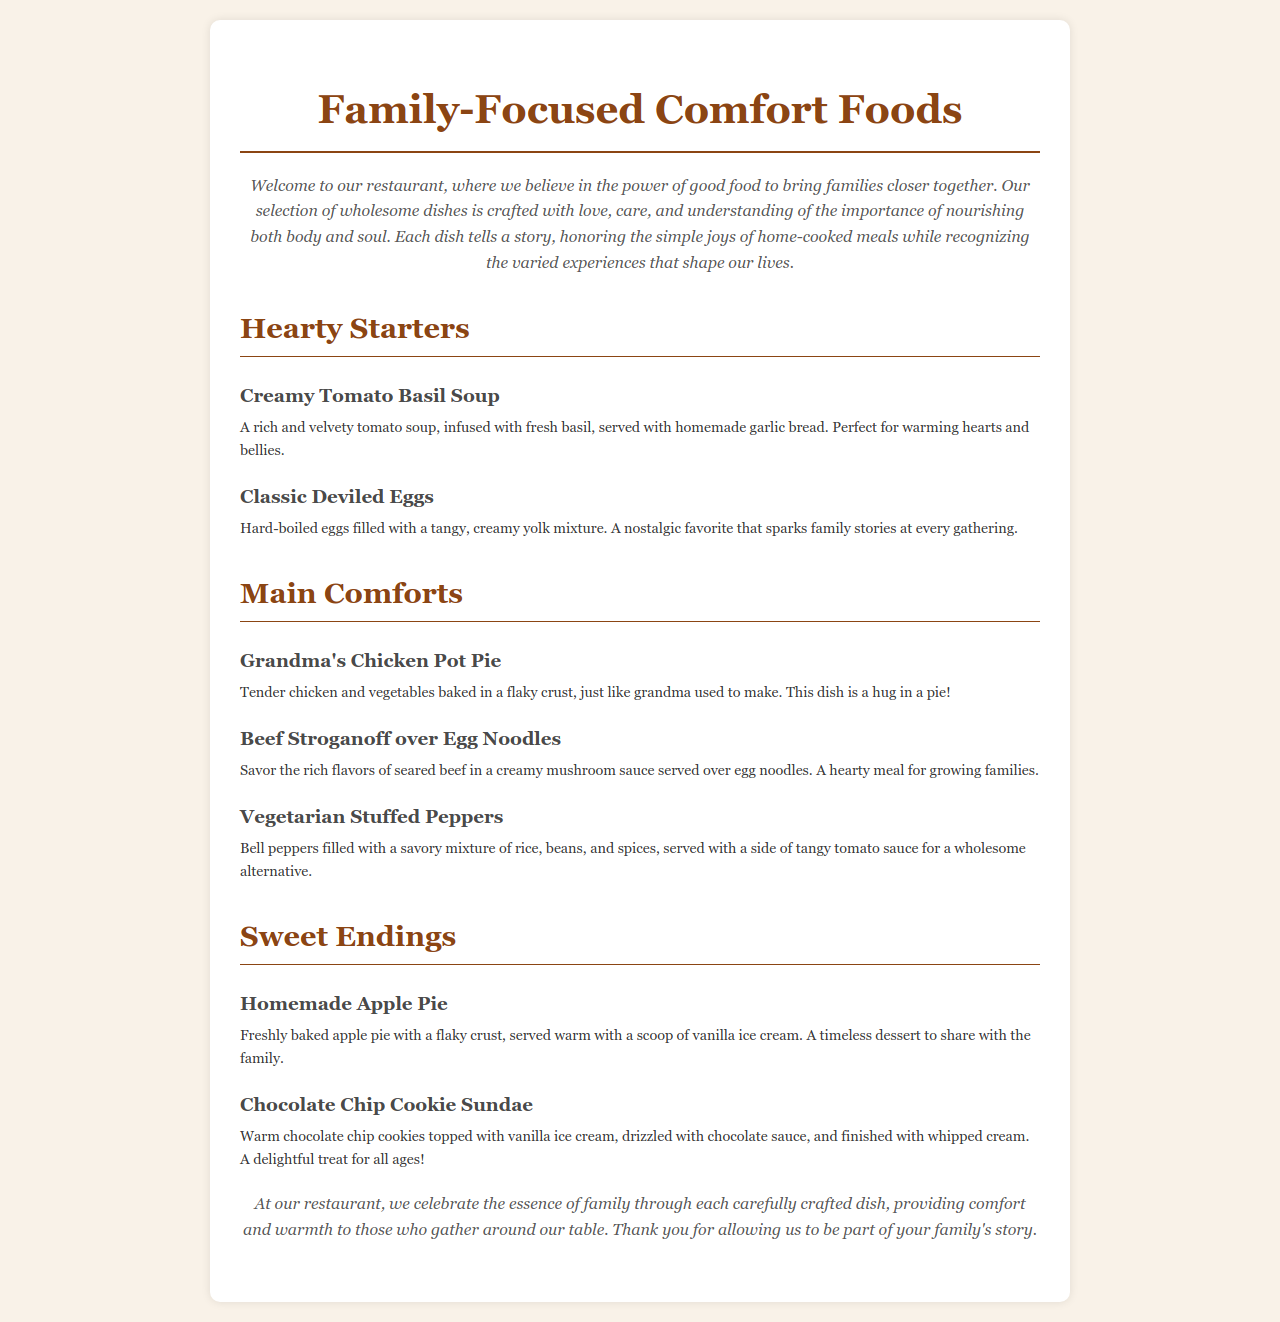What is the title of the menu? The title of the menu is prominently displayed at the top of the document.
Answer: Family-Focused Comfort Foods How many Hearty Starters are listed? The document lists all the items in the Hearty Starters section.
Answer: 2 What is the main ingredient in Grandma's Chicken Pot Pie? The document describes the contents of Grandma's Chicken Pot Pie.
Answer: Chicken Which dessert is served warm with a scoop of ice cream? The menu provides a description indicating which dessert includes ice cream.
Answer: Homemade Apple Pie What type of sauce is served with the Vegetarian Stuffed Peppers? The description of the Vegetarian Stuffed Peppers includes the accompanying sauce.
Answer: Tomato sauce How does the restaurant describe its overall goal? The document states the intention behind the menu and the dishes offered.
Answer: Celebrate the essence of family 